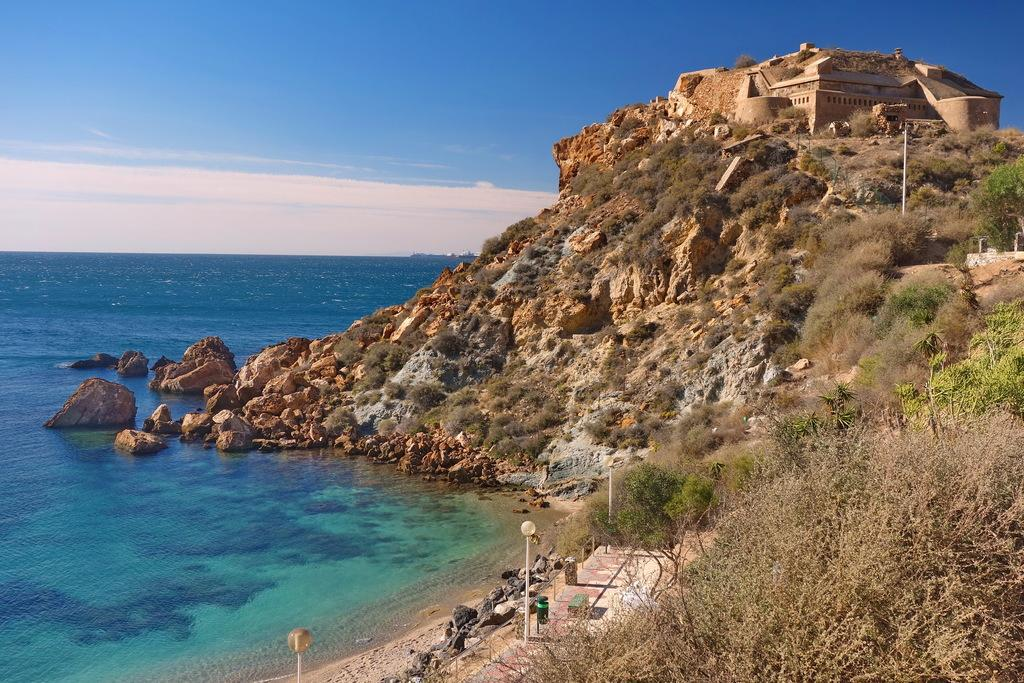What can be seen in the sky in the image? The sky with clouds is visible in the image. What type of natural feature is present in the image? There is a sea in the image. What kind of geological features can be seen in the image? Rocks and stones are present in the image. What man-made structures are visible in the image? Street poles and street lights are present in the image. What type of vegetation is visible in the image? Trees are visible in the image. What is the location of the building in the image? There is a building on top of a hill in the image. Can you tell me how many times mom comforts the child while they swim in the image? There is no child or mom present in the image, and therefore no swimming or comforting can be observed. 